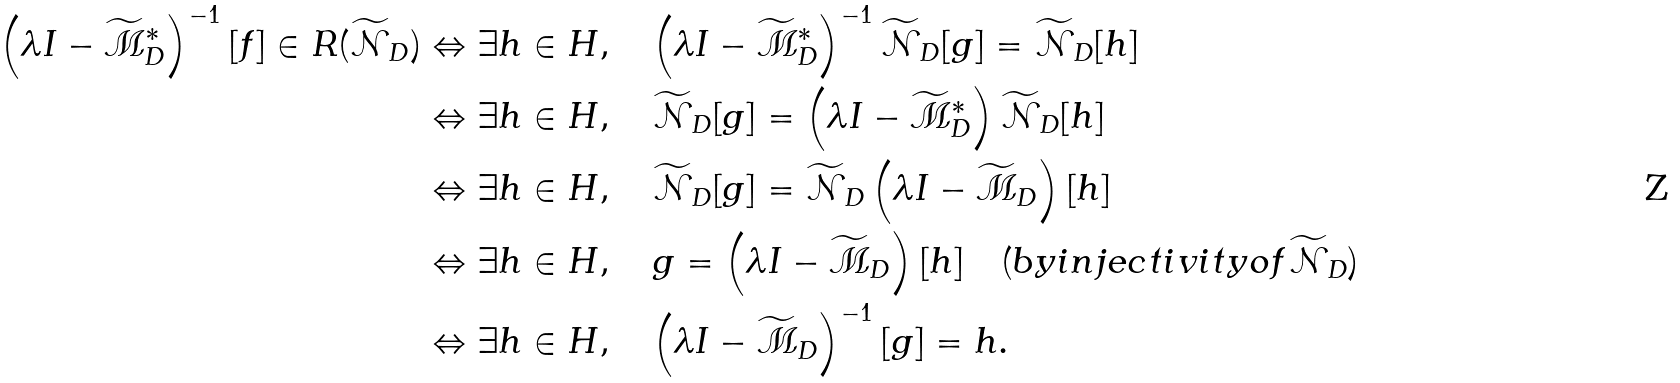<formula> <loc_0><loc_0><loc_500><loc_500>\left ( \lambda I - \widetilde { \mathcal { M } } ^ { * } _ { D } \right ) ^ { - 1 } [ { f } ] \in R ( \widetilde { \mathcal { N } } _ { D } ) & \Leftrightarrow \exists { h } \in H , \quad \left ( \lambda I - \widetilde { \mathcal { M } } ^ { * } _ { D } \right ) ^ { - 1 } \widetilde { \mathcal { N } } _ { D } [ { g } ] = \widetilde { \mathcal { N } } _ { D } [ { h } ] \\ & \Leftrightarrow \exists { h } \in H , \quad \widetilde { \mathcal { N } } _ { D } [ { g } ] = \left ( \lambda I - \widetilde { \mathcal { M } } _ { D } ^ { * } \right ) \widetilde { \mathcal { N } } _ { D } [ { h } ] \\ & \Leftrightarrow \exists { h } \in H , \quad \widetilde { \mathcal { N } } _ { D } [ { g } ] = \widetilde { \mathcal { N } } _ { D } \left ( \lambda I - \widetilde { \mathcal { M } } _ { D } \right ) [ { h } ] \\ & \Leftrightarrow \exists { h } \in H , \quad g = \left ( \lambda I - \widetilde { \mathcal { M } } _ { D } \right ) [ { h } ] \quad ( b y i n j e c t i v i t y o f \widetilde { \mathcal { N } } _ { D } ) \\ & \Leftrightarrow \exists { h } \in H , \quad \left ( \lambda I - \widetilde { \mathcal { M } } _ { D } \right ) ^ { - 1 } [ { g } ] = { h } .</formula> 